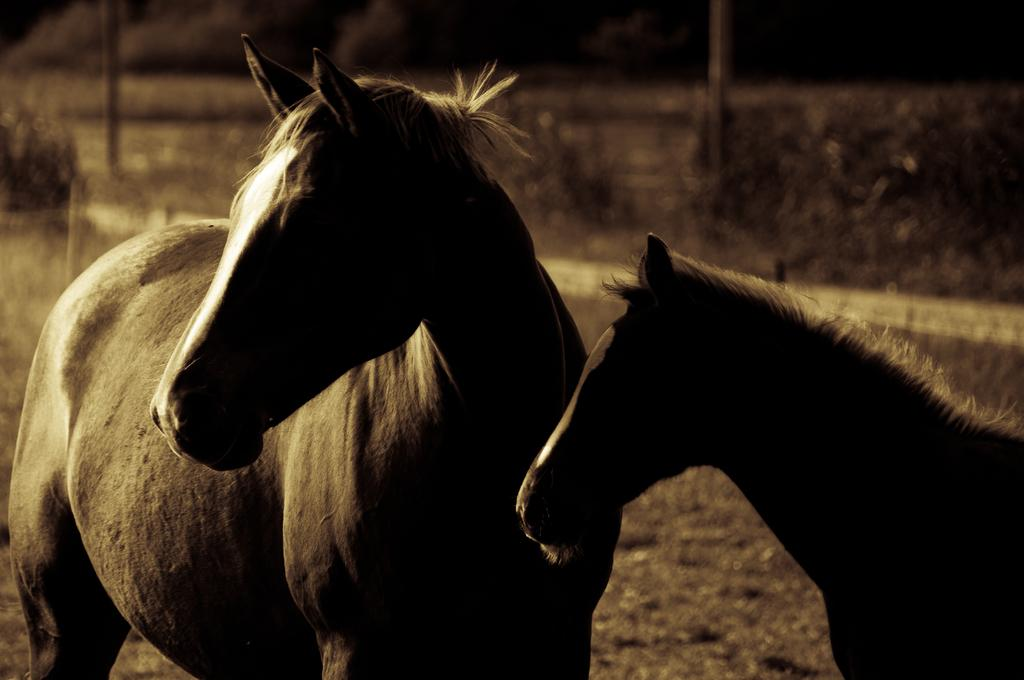What animals are in the front of the image? There are horses in the front of the image. What type of vegetation can be seen in the background of the image? There are plants in the background of the image. What structures are present in the image? There are poles in the image. What type of business is being conducted by the farmer in the image? There is no farmer or business activity present in the image; it features horses and plants. What kind of apparatus is being used by the horses in the image? There is no apparatus being used by the horses in the image; they are simply standing in the front. 